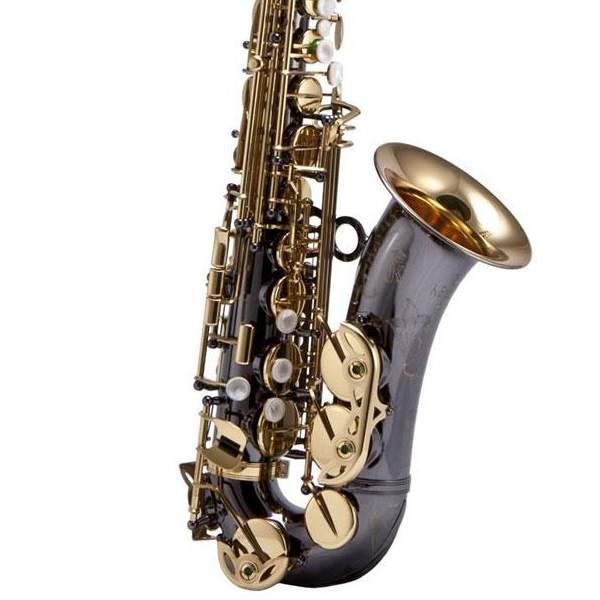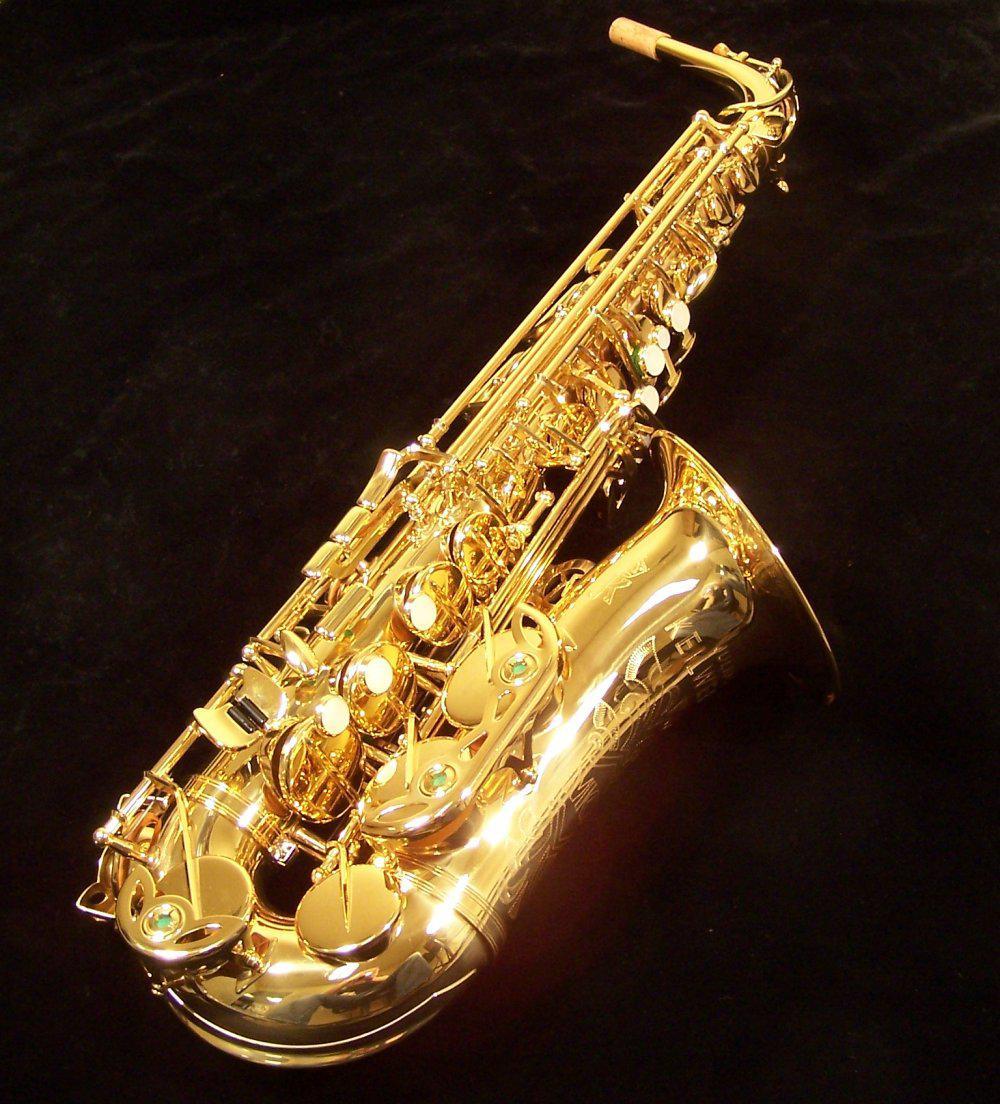The first image is the image on the left, the second image is the image on the right. Considering the images on both sides, is "The saxophone on the right side is on a black background." valid? Answer yes or no. Yes. The first image is the image on the left, the second image is the image on the right. For the images displayed, is the sentence "there are two saxophones and one case in the pair of images." factually correct? Answer yes or no. No. 